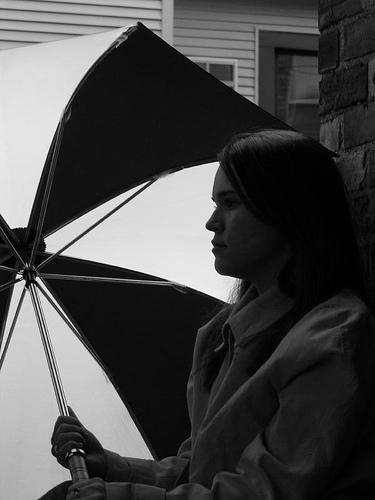How many different colors are on the umbrella?
Short answer required. 2. What is the person holding?
Concise answer only. Umbrella. What is the woman sitting against?
Concise answer only. Wall. Is it raining?
Quick response, please. No. 